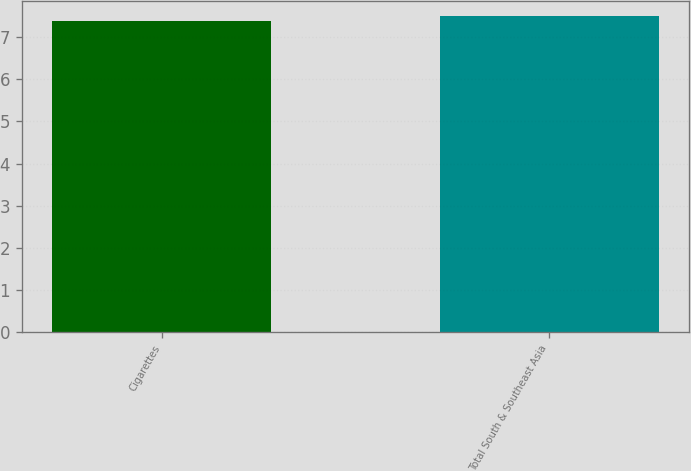Convert chart to OTSL. <chart><loc_0><loc_0><loc_500><loc_500><bar_chart><fcel>Cigarettes<fcel>Total South & Southeast Asia<nl><fcel>7.4<fcel>7.5<nl></chart> 